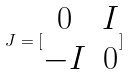<formula> <loc_0><loc_0><loc_500><loc_500>J = [ \begin{matrix} 0 & I \\ - I & 0 \end{matrix} ]</formula> 